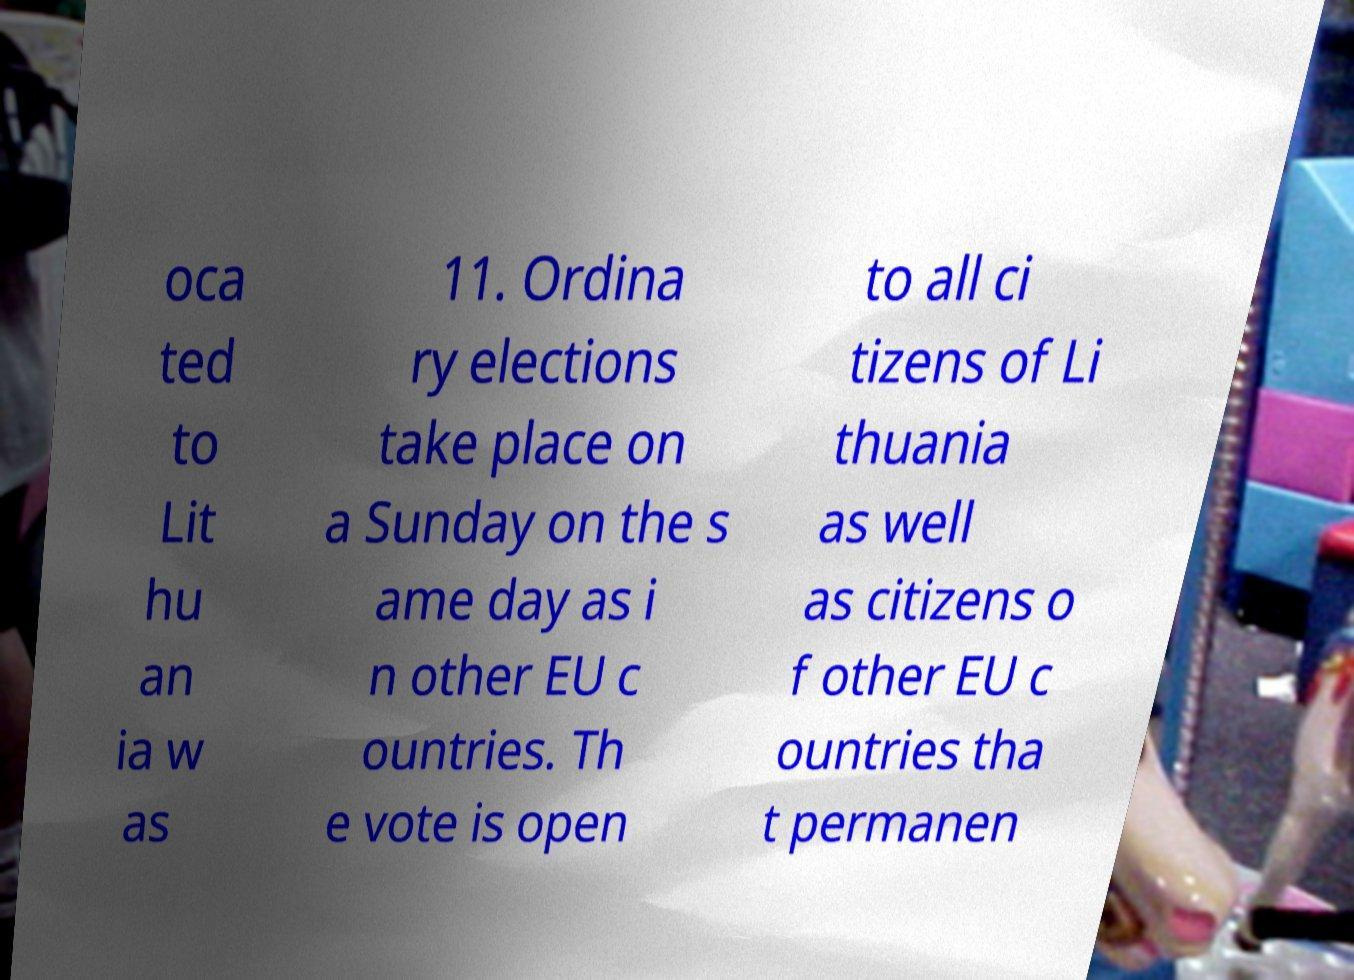Can you accurately transcribe the text from the provided image for me? oca ted to Lit hu an ia w as 11. Ordina ry elections take place on a Sunday on the s ame day as i n other EU c ountries. Th e vote is open to all ci tizens of Li thuania as well as citizens o f other EU c ountries tha t permanen 